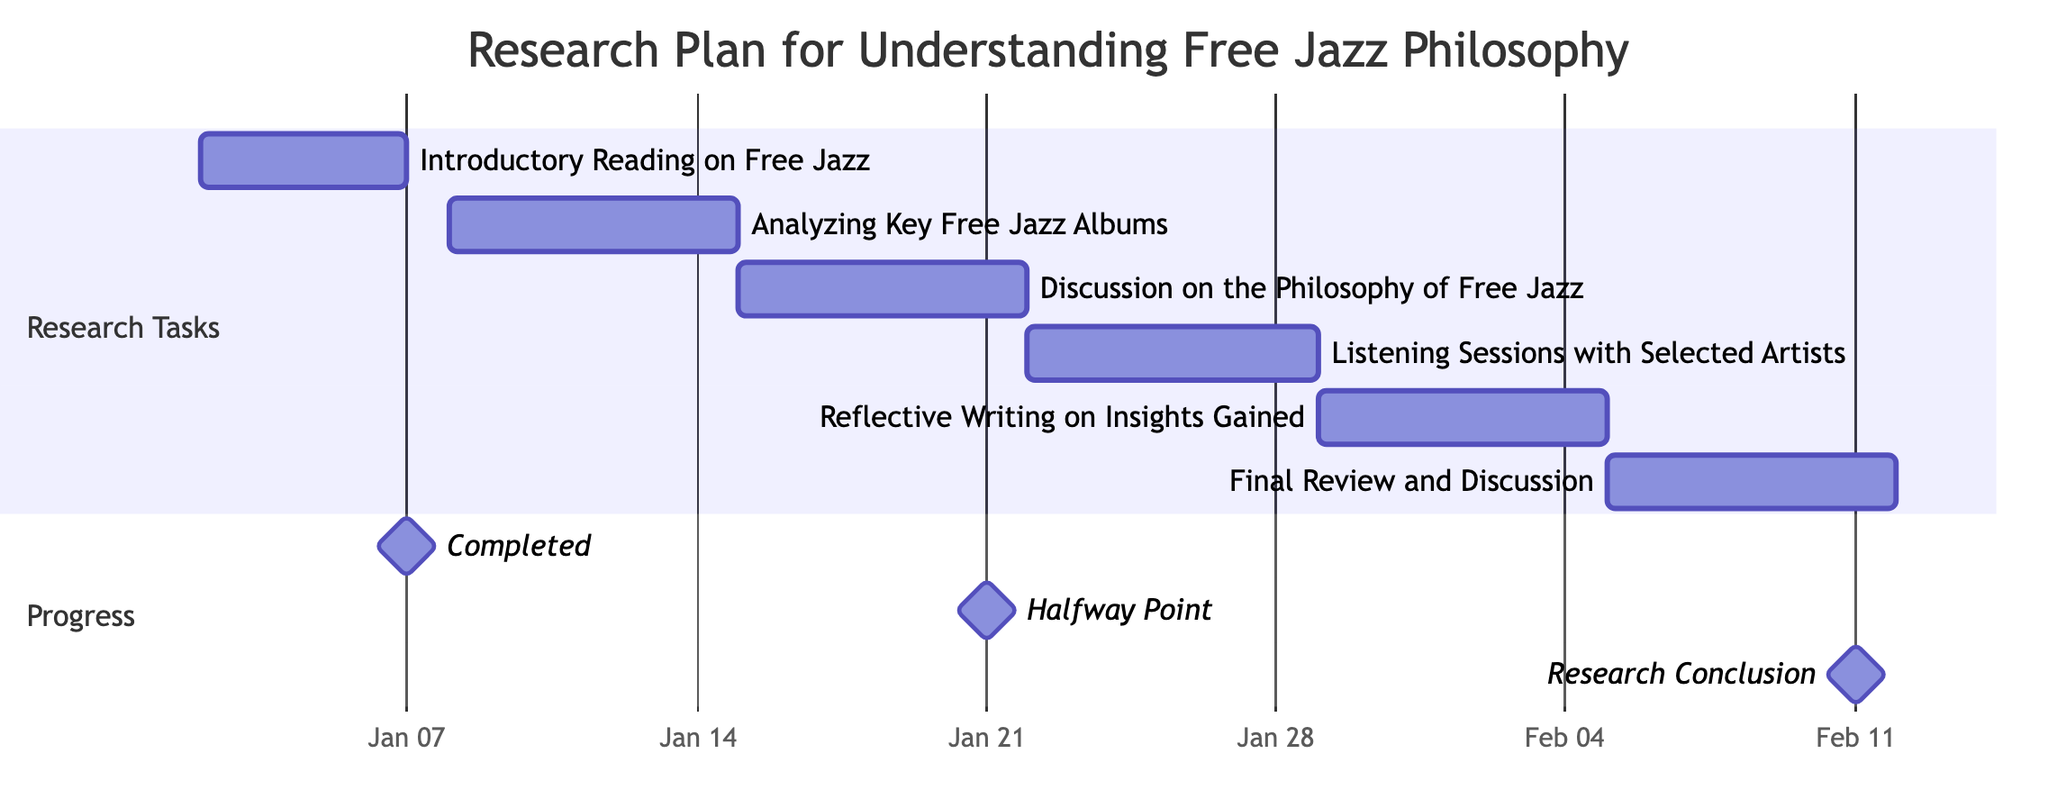What is the duration of the "Introductory Reading on Free Jazz"? The diagram specifies that the "Introductory Reading on Free Jazz" has a duration of 5 days, as indicated next to the task in the Gantt Chart.
Answer: 5 days On what date does the "Final Review and Discussion" start? Looking at the Gantt Chart, the "Final Review and Discussion" starts on February 5, 2024, as shown in the timeline under the task.
Answer: February 5, 2024 How many tasks are scheduled in total? By counting the individual tasks listed in the Gantt Chart, there are 6 tasks detailed, each representing a different aspect of the research plan.
Answer: 6 Which task overlaps with the "Listening Sessions with Selected Artists"? The "Listening Sessions with Selected Artists" runs from January 22 to January 28, and the task that overlaps with it is "Discussion on the Philosophy of Free Jazz", which runs from January 15 to January 21, indicating they are adjacent but do not overlap. No other tasks overlap during this time.
Answer: None What is the total length of the research plan? The research plan spans from the start date of the first task on January 2, 2024, to the end date of the last task on February 11, 2024. To determine the total length, we note that there are a total of 40 days from the start to the conclusion.
Answer: 40 days Which task follows the "Analyzing Key Free Jazz Albums"? The "Discussion on the Philosophy of Free Jazz" follows the "Analyzing Key Free Jazz Albums", as indicated by the timeline, starting on January 15, 2024, right after the completion of the previous task that ends on January 14.
Answer: Discussion on the Philosophy of Free Jazz When does the halfway point of the research occur? The halfway point, as marked in the Gantt Chart, occurs on January 21, 2024, which indicates that halfway through the timeline, the tasks scheduled up to that date are completed.
Answer: January 21, 2024 Which task takes the longest time to complete? Examining all the tasks, each has a specified duration, and since the longest duration noted is 7 days for several tasks, they all have the same longest duration.
Answer: 7 days 